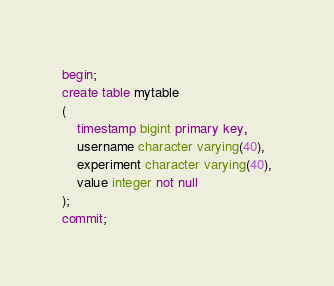<code> <loc_0><loc_0><loc_500><loc_500><_SQL_>begin;
create table mytable
(
    timestamp bigint primary key,
    username character varying(40),
    experiment character varying(40),
    value integer not null
);
commit;
</code> 